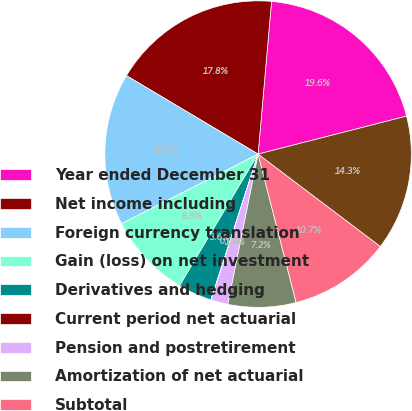Convert chart to OTSL. <chart><loc_0><loc_0><loc_500><loc_500><pie_chart><fcel>Year ended December 31<fcel>Net income including<fcel>Foreign currency translation<fcel>Gain (loss) on net investment<fcel>Derivatives and hedging<fcel>Current period net actuarial<fcel>Pension and postretirement<fcel>Amortization of net actuarial<fcel>Subtotal<fcel>Total comprehensive income<nl><fcel>19.62%<fcel>17.84%<fcel>16.06%<fcel>8.93%<fcel>3.58%<fcel>0.02%<fcel>1.8%<fcel>7.15%<fcel>10.71%<fcel>14.28%<nl></chart> 